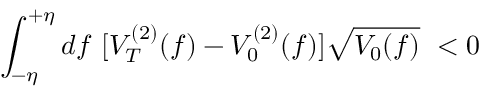<formula> <loc_0><loc_0><loc_500><loc_500>\int _ { - \eta } ^ { + \eta } d f [ V _ { T } ^ { ( 2 ) } ( f ) - V _ { 0 } ^ { ( 2 ) } ( f ) ] \sqrt { V _ { 0 } ( f ) } < 0</formula> 